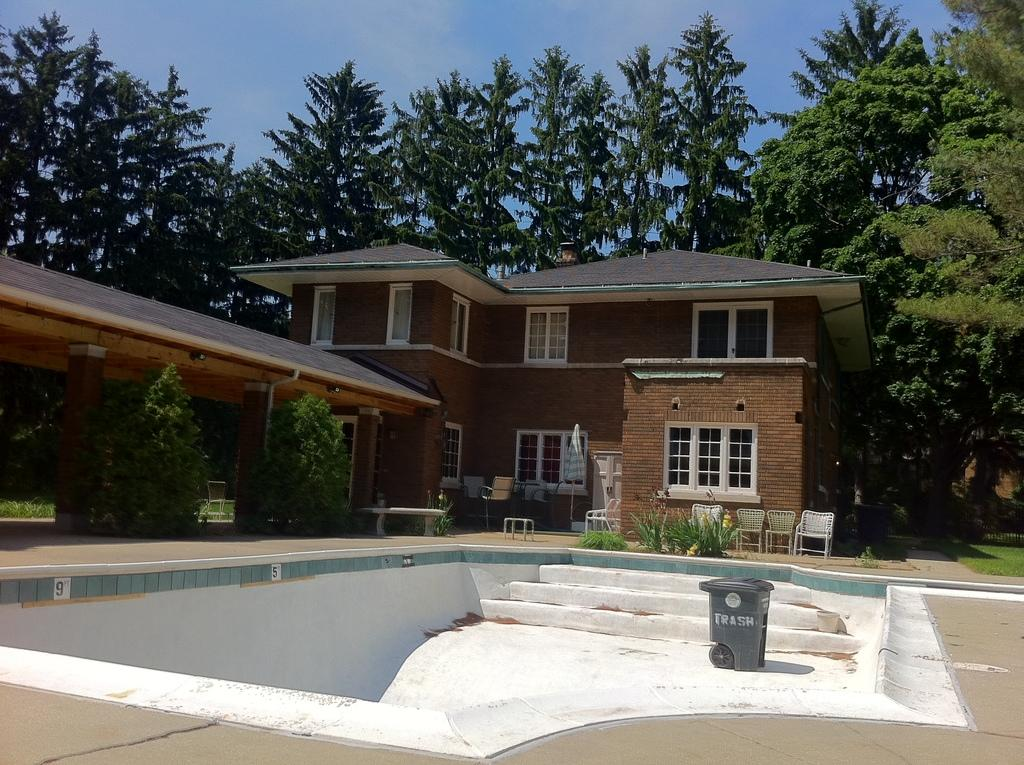What type of structure is visible in the image? There is a house in the image. What furniture can be seen in the image? There are chairs in the image. What type of vegetation is present in the image? There are trees in the image. Where is the dustbin located in relation to the house? There is a dustbin in front of the house. What type of jam is being served on the ship in the image? There is no ship or jam present in the image; it features a house, chairs, trees, and a dustbin. 